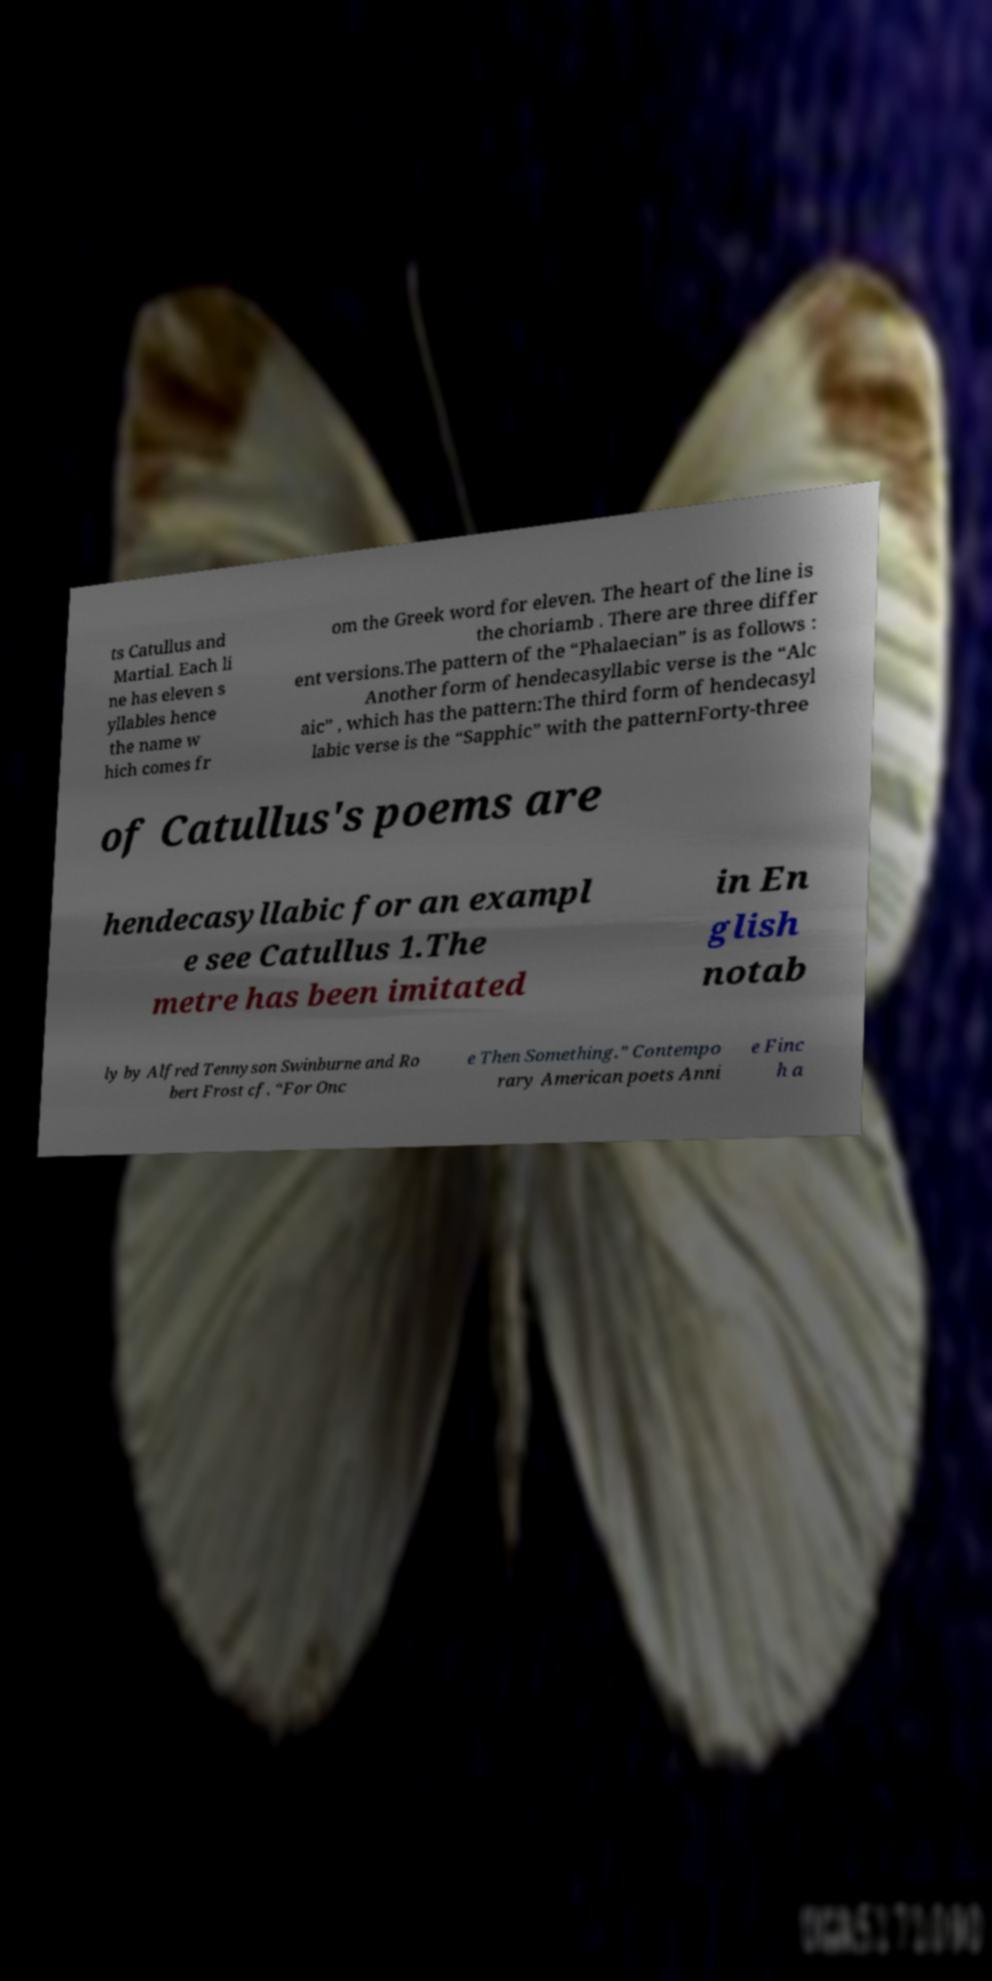Could you assist in decoding the text presented in this image and type it out clearly? ts Catullus and Martial. Each li ne has eleven s yllables hence the name w hich comes fr om the Greek word for eleven. The heart of the line is the choriamb . There are three differ ent versions.The pattern of the “Phalaecian” is as follows : Another form of hendecasyllabic verse is the “Alc aic” , which has the pattern:The third form of hendecasyl labic verse is the “Sapphic” with the patternForty-three of Catullus's poems are hendecasyllabic for an exampl e see Catullus 1.The metre has been imitated in En glish notab ly by Alfred Tennyson Swinburne and Ro bert Frost cf. “For Onc e Then Something.” Contempo rary American poets Anni e Finc h a 